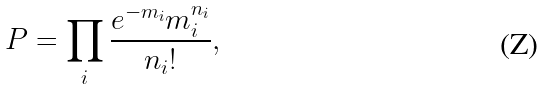<formula> <loc_0><loc_0><loc_500><loc_500>P = \prod _ { i } \frac { e ^ { - m _ { i } } m _ { i } ^ { n _ { i } } } { n _ { i } ! } ,</formula> 